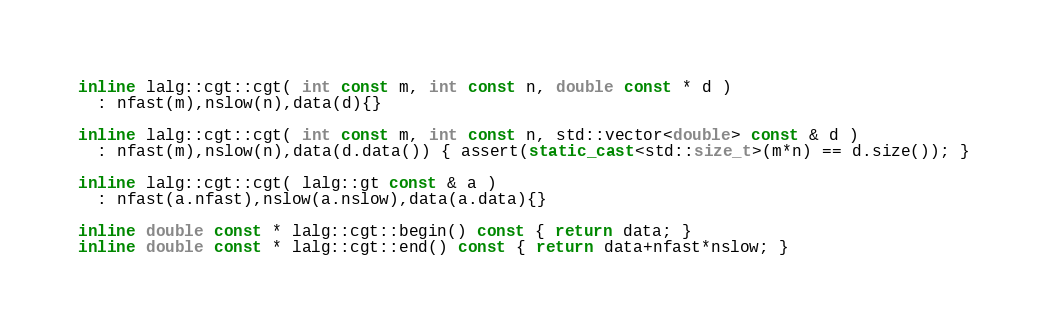<code> <loc_0><loc_0><loc_500><loc_500><_C++_>inline lalg::cgt::cgt( int const m, int const n, double const * d ) 
  : nfast(m),nslow(n),data(d){}

inline lalg::cgt::cgt( int const m, int const n, std::vector<double> const & d ) 
  : nfast(m),nslow(n),data(d.data()) { assert(static_cast<std::size_t>(m*n) == d.size()); }
    
inline lalg::cgt::cgt( lalg::gt const & a )
  : nfast(a.nfast),nslow(a.nslow),data(a.data){}

inline double const * lalg::cgt::begin() const { return data; }
inline double const * lalg::cgt::end() const { return data+nfast*nslow; }

</code> 